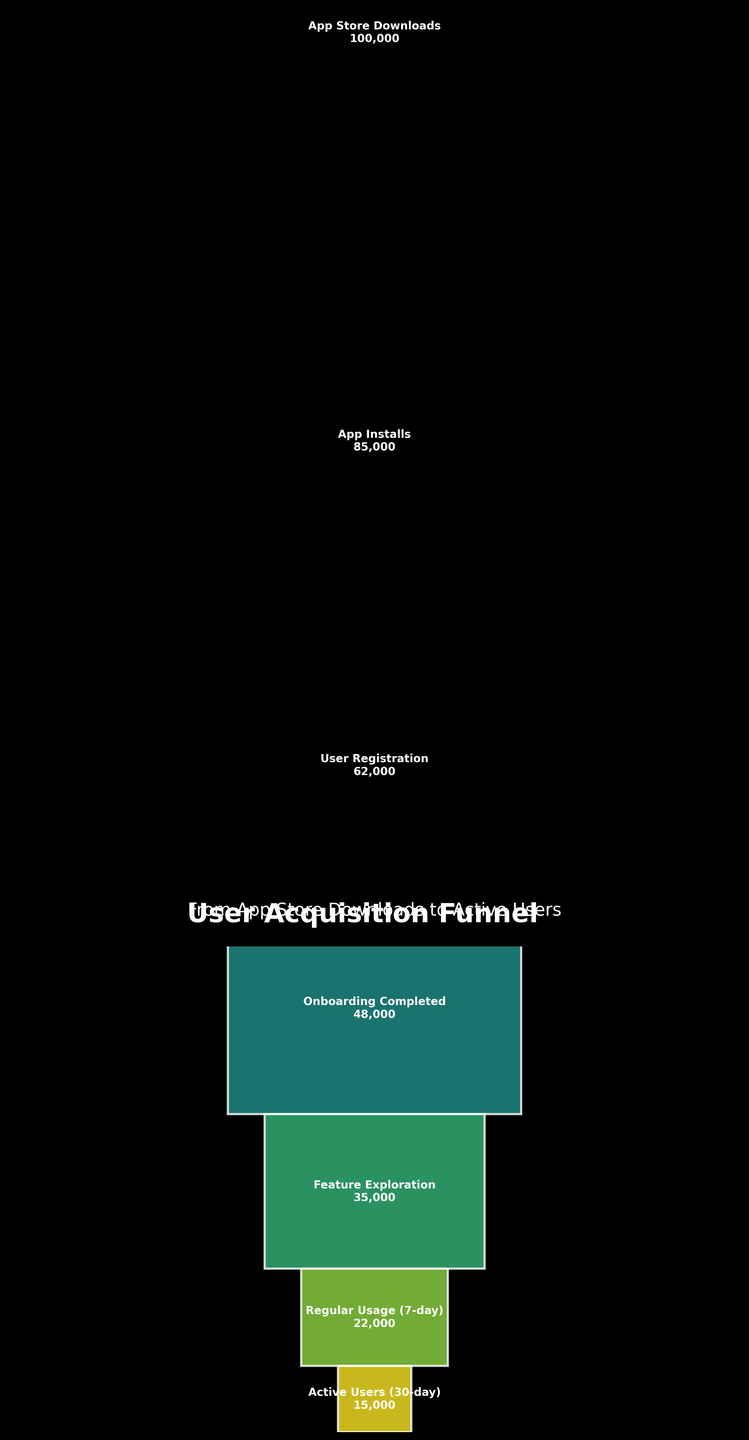How many stages are represented in the user acquisition funnel? There are a total of 7 stages mentioned in the data from 'App Store Downloads' to 'Active Users (30-day)'
Answer: 7 Which stage has the largest number of users? 'App Store Downloads' has the largest number of users with 100,000 users as stated in the data.
Answer: App Store Downloads How many users completed the onboarding process? The figure shows that 'Onboarding Completed' has 48,000 users.
Answer: 48,000 What is the decrease in the number of users from 'User Registration' to 'Onboarding Completed'? The number of users at 'User Registration' is 62,000 and at 'Onboarding Completed' is 48,000. So, the decrease is 62,000 - 48,000 = 14,000
Answer: 14,000 What is the percentage of users that move from 'App Store Downloads' to 'App Installs'? The number of users at 'App Installs' is 85,000 and at 'App Store Downloads' is 100,000. The percentage is (85,000 / 100,000) * 100 = 85%
Answer: 85% Which two stages have the smallest gap in the number of users? Comparing the users at each stage: App Store Downloads to App Installs (15,000), App Installs to User Registration (23,000), User Registration to Onboarding Completed (14,000), Onboarding Completed to Feature Exploration (13,000), Feature Exploration to Regular Usage (7-day) (13,000), and Regular Usage (7-day) to Active Users (30-day) (7,000), the smallest gap is between 'Regular Usage (7-day)' and 'Active Users (30-day)' with a difference of 7,000 users.
Answer: Regular Usage (7-day) and Active Users (30-day) What is the total number of users listed for all stages combined? Sum all users across stages: 100,000 + 85,000 + 62,000 + 48,000 + 35,000 + 22,000 + 15,000 = 367,000
Answer: 367,000 At which stage do approximately half of the initial 'App Store Downloads' users drop off? By examining the numbers, the 'Onboarding Completed' stage with 48,000 users is less than half of the initial 100,000 'App Store Downloads' users.
Answer: Onboarding Completed What is the ratio of 'Regular Usage (7-day)' users to 'Onboarding Completed' users? Number of users at 'Regular Usage (7-day)' is 22,000 and at 'Onboarding Completed' is 48,000. The ratio is 22,000:48,000 which simplifies to 11:24.
Answer: 11:24 Which stage has a user count that is exactly 35% of the 'App Store Downloads' stage? 'Feature Exploration' has 35,000 users. To check: 35% of 100,000 is 35,000 (0.35 * 100,000 = 35,000).
Answer: Feature Exploration 